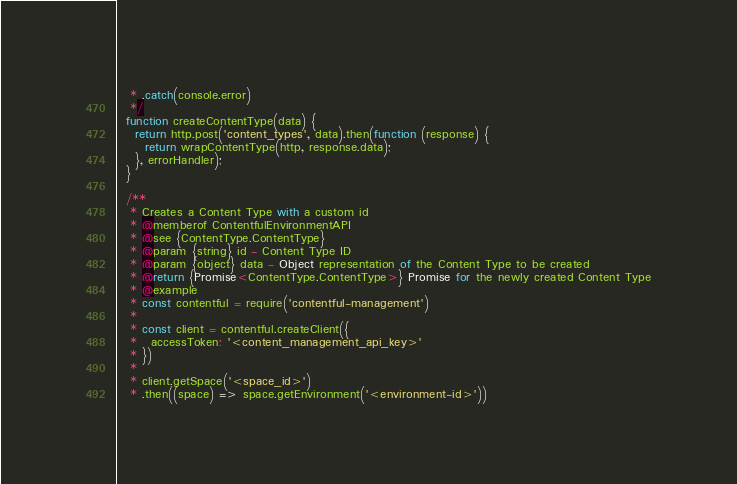<code> <loc_0><loc_0><loc_500><loc_500><_JavaScript_>   * .catch(console.error)
   */
  function createContentType(data) {
    return http.post('content_types', data).then(function (response) {
      return wrapContentType(http, response.data);
    }, errorHandler);
  }

  /**
   * Creates a Content Type with a custom id
   * @memberof ContentfulEnvironmentAPI
   * @see {ContentType.ContentType}
   * @param {string} id - Content Type ID
   * @param {object} data - Object representation of the Content Type to be created
   * @return {Promise<ContentType.ContentType>} Promise for the newly created Content Type
   * @example
   * const contentful = require('contentful-management')
   *
   * const client = contentful.createClient({
   *   accessToken: '<content_management_api_key>'
   * })
   *
   * client.getSpace('<space_id>')
   * .then((space) => space.getEnvironment('<environment-id>'))</code> 